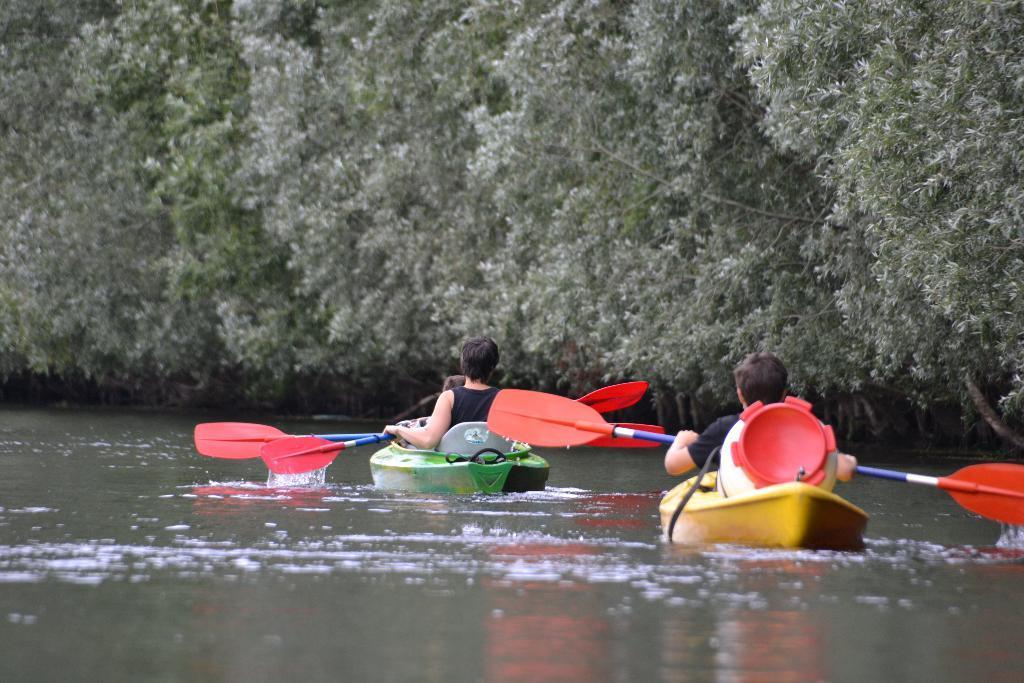How would you summarize this image in a sentence or two? In this image there are two inflatable boats are sailing on a river, in that boats there are three persons sitting, in the background there are trees. 